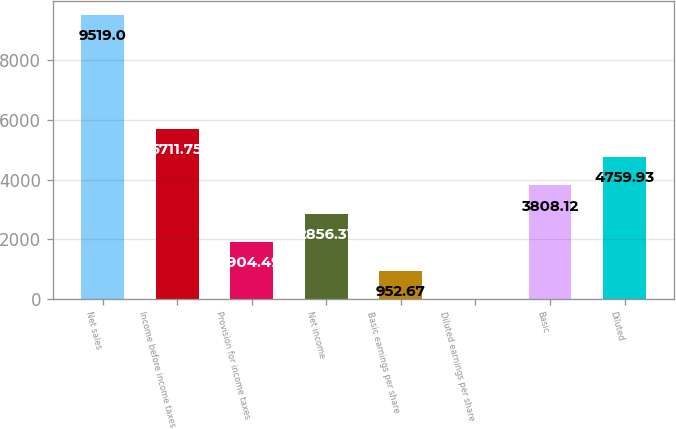Convert chart to OTSL. <chart><loc_0><loc_0><loc_500><loc_500><bar_chart><fcel>Net sales<fcel>Income before income taxes<fcel>Provision for income taxes<fcel>Net income<fcel>Basic earnings per share<fcel>Diluted earnings per share<fcel>Basic<fcel>Diluted<nl><fcel>9519<fcel>5711.75<fcel>1904.49<fcel>2856.31<fcel>952.67<fcel>0.85<fcel>3808.12<fcel>4759.93<nl></chart> 